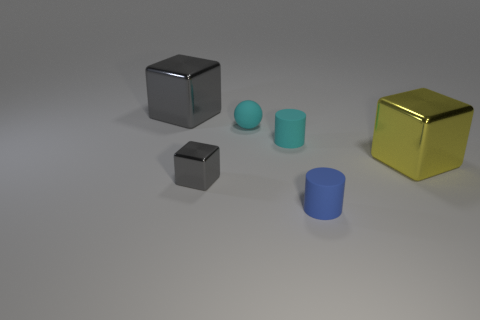Add 2 big gray cubes. How many objects exist? 8 Subtract all cylinders. How many objects are left? 4 Add 2 large blue metal things. How many large blue metal things exist? 2 Subtract 0 yellow spheres. How many objects are left? 6 Subtract all large rubber things. Subtract all tiny matte balls. How many objects are left? 5 Add 5 small blue objects. How many small blue objects are left? 6 